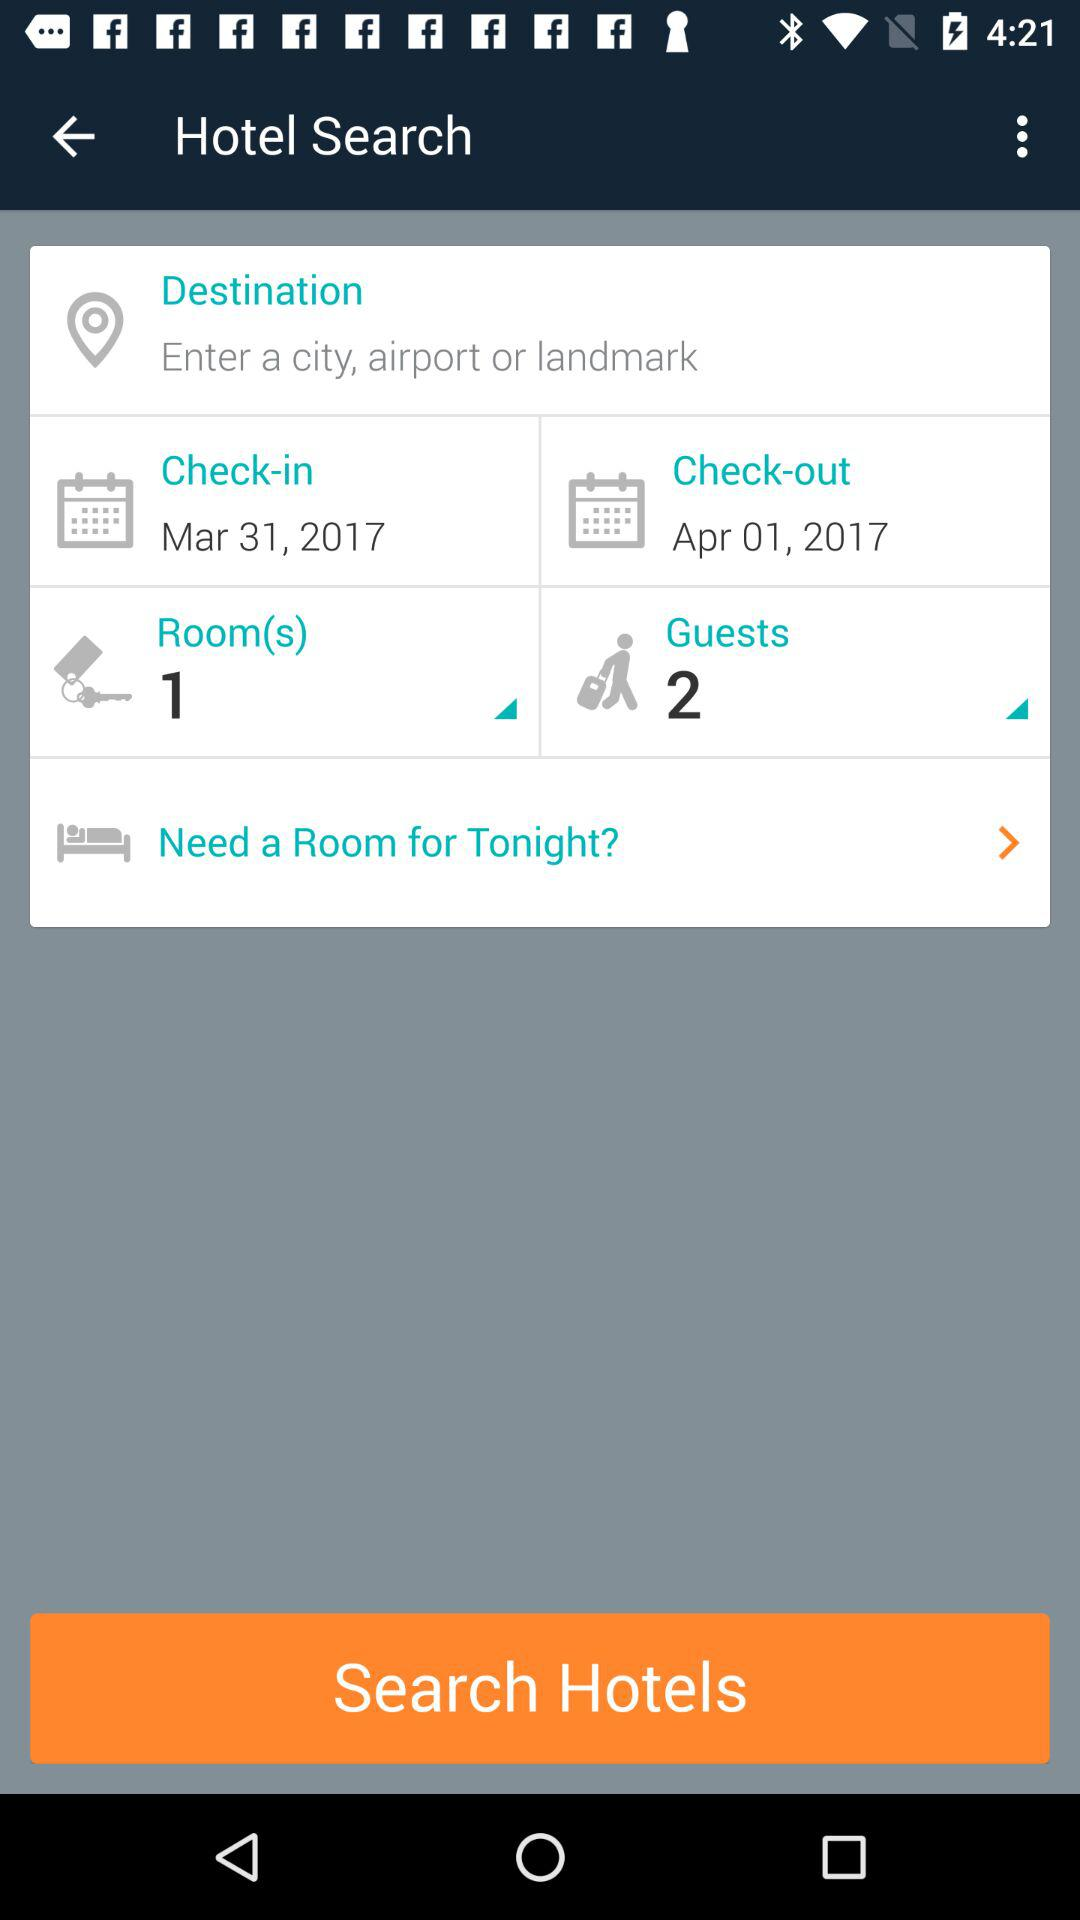What is the check-out date? The check-out date is April 1, 2017. 